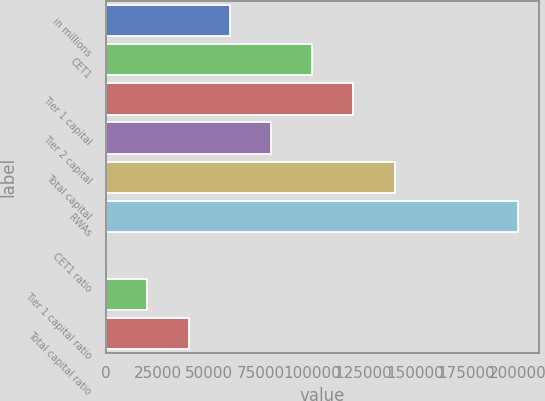<chart> <loc_0><loc_0><loc_500><loc_500><bar_chart><fcel>in millions<fcel>CET1<fcel>Tier 1 capital<fcel>Tier 2 capital<fcel>Total capital<fcel>RWAs<fcel>CET1 ratio<fcel>Tier 1 capital ratio<fcel>Total capital ratio<nl><fcel>60035.1<fcel>100050<fcel>120058<fcel>80042.8<fcel>140066<fcel>200089<fcel>12<fcel>20019.7<fcel>40027.4<nl></chart> 